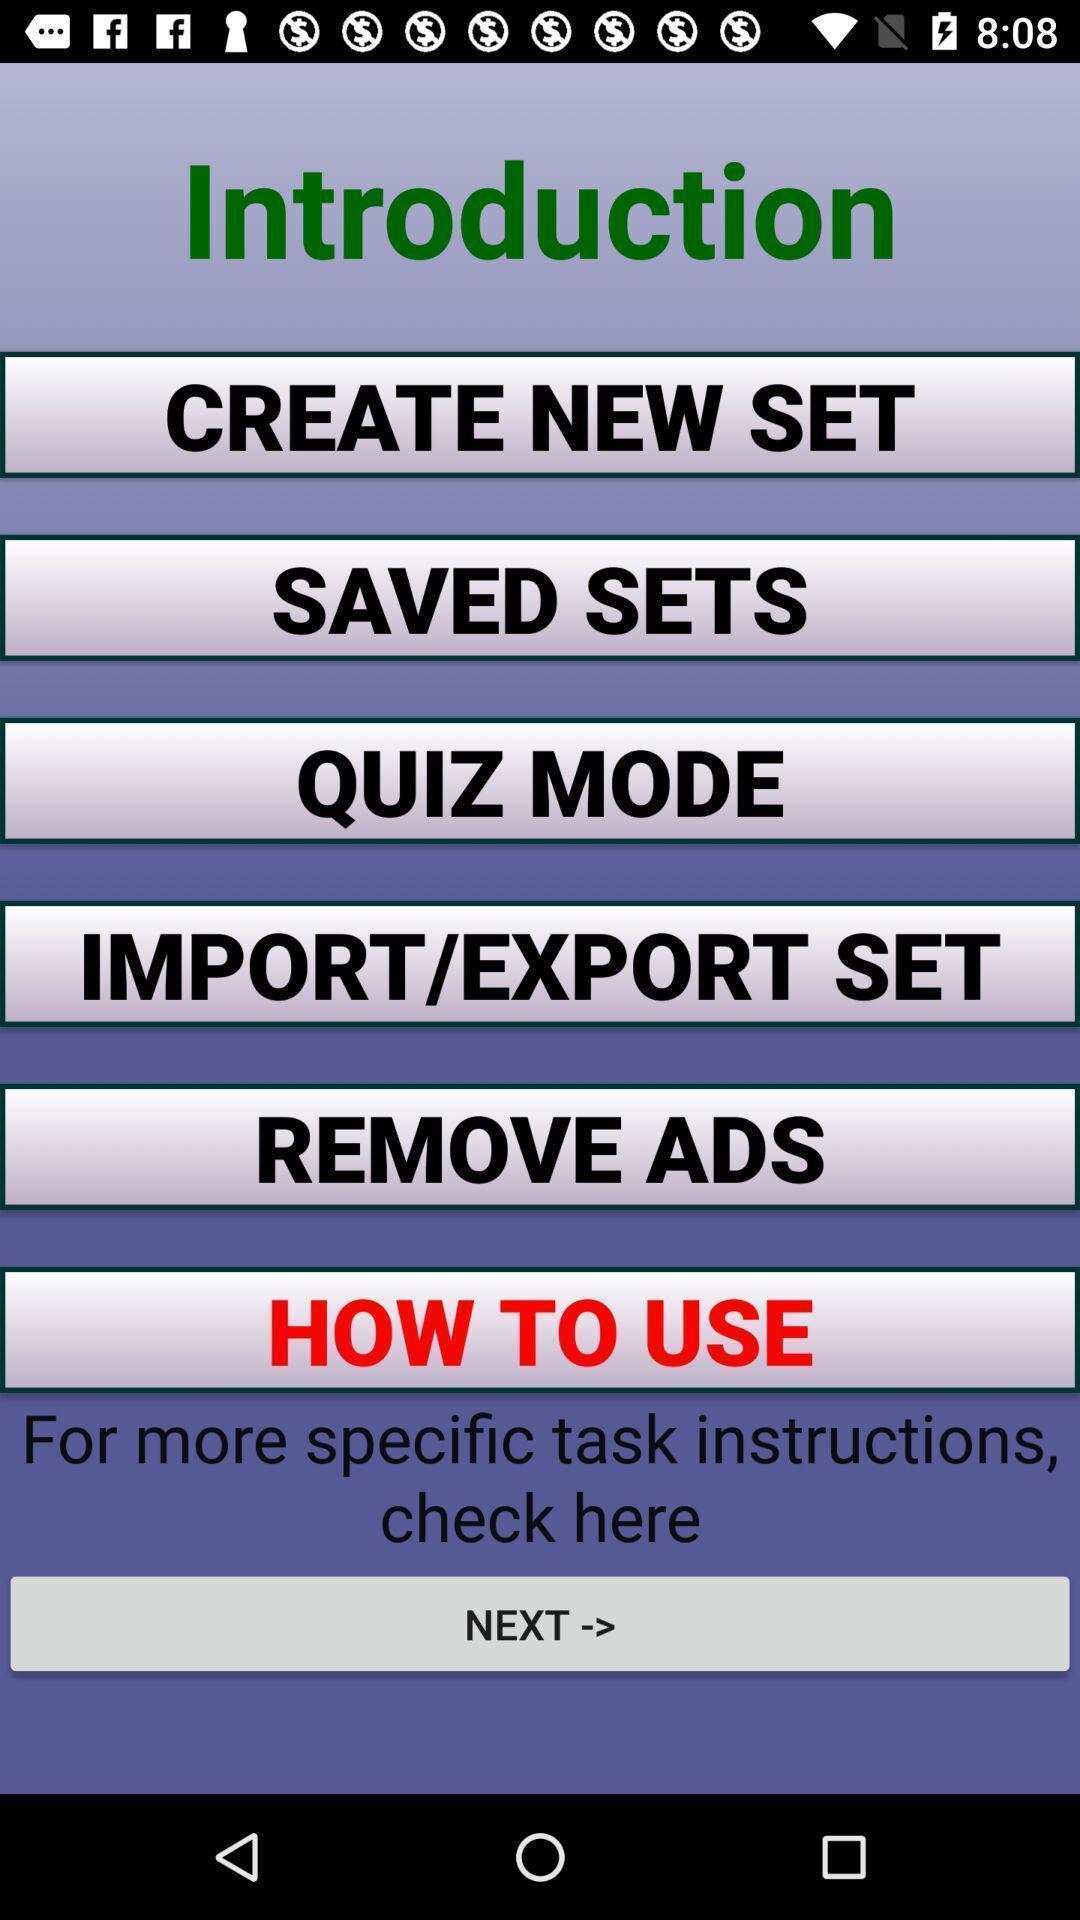What can you discern from this picture? List of options available in a studying app. 